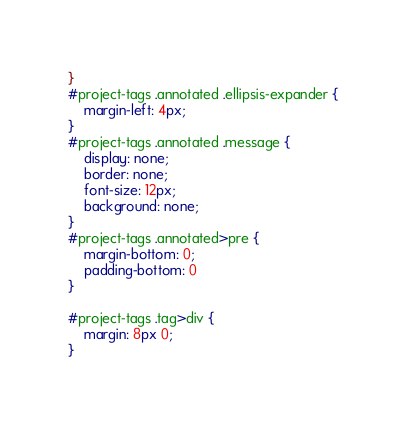Convert code to text. <code><loc_0><loc_0><loc_500><loc_500><_CSS_>}
#project-tags .annotated .ellipsis-expander {
	margin-left: 4px;
}
#project-tags .annotated .message {
	display: none;
	border: none;
	font-size: 12px;
	background: none;
}
#project-tags .annotated>pre {
	margin-bottom: 0;
	padding-bottom: 0
}

#project-tags .tag>div {
	margin: 8px 0;
}

</code> 